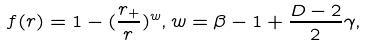Convert formula to latex. <formula><loc_0><loc_0><loc_500><loc_500>f ( r ) = 1 - ( \frac { r _ { + } } { r } ) ^ { w } , w = \beta - 1 + \frac { D - 2 } { 2 } \gamma ,</formula> 